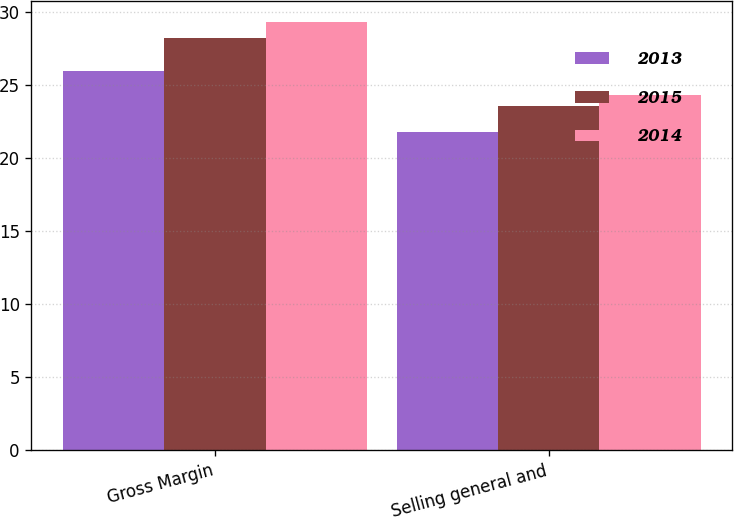Convert chart. <chart><loc_0><loc_0><loc_500><loc_500><stacked_bar_chart><ecel><fcel>Gross Margin<fcel>Selling general and<nl><fcel>2013<fcel>26<fcel>21.8<nl><fcel>2015<fcel>28.2<fcel>23.6<nl><fcel>2014<fcel>29.3<fcel>24.3<nl></chart> 